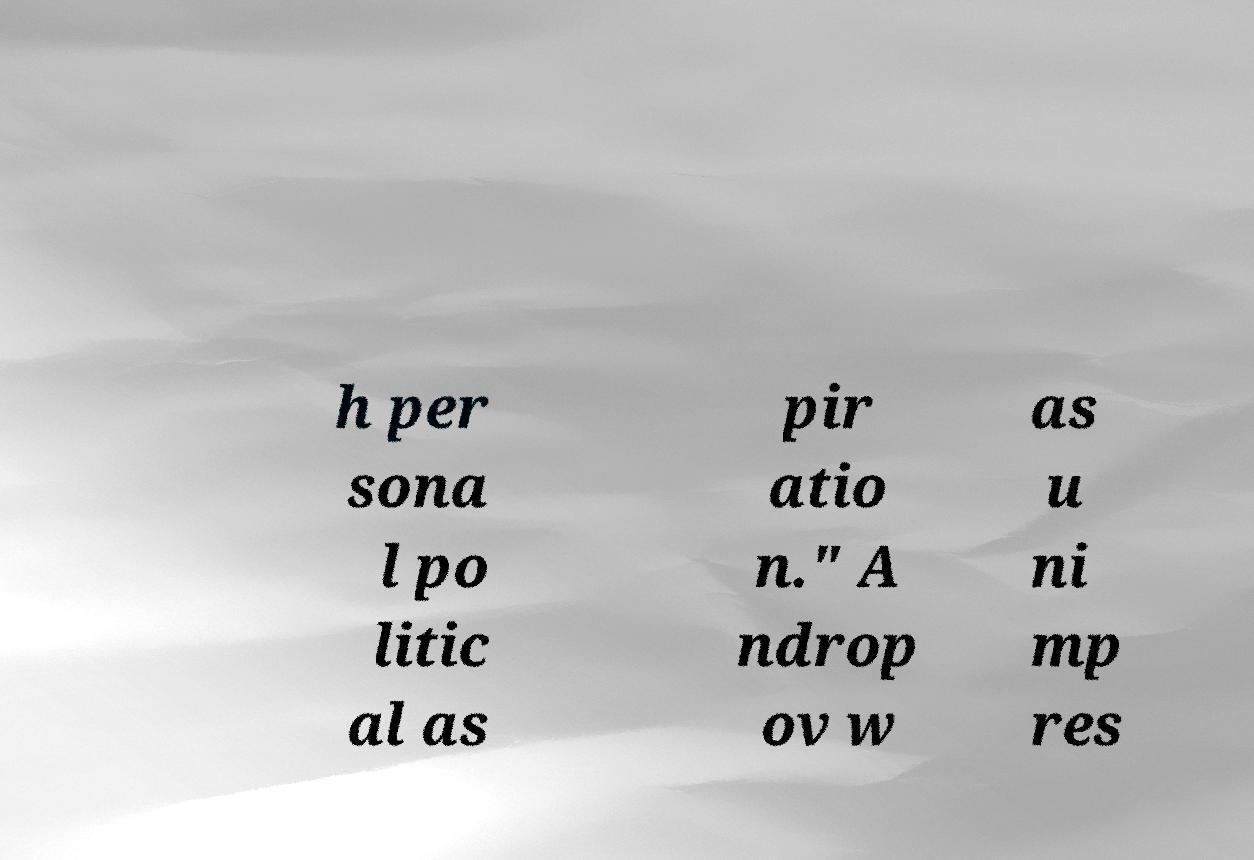Please identify and transcribe the text found in this image. h per sona l po litic al as pir atio n." A ndrop ov w as u ni mp res 